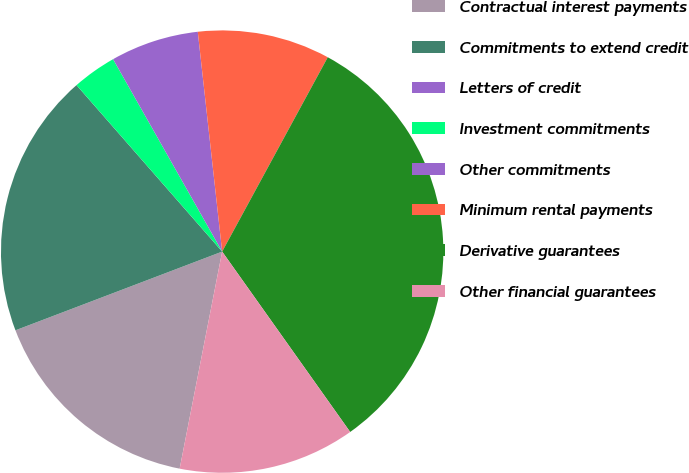Convert chart to OTSL. <chart><loc_0><loc_0><loc_500><loc_500><pie_chart><fcel>Contractual interest payments<fcel>Commitments to extend credit<fcel>Letters of credit<fcel>Investment commitments<fcel>Other commitments<fcel>Minimum rental payments<fcel>Derivative guarantees<fcel>Other financial guarantees<nl><fcel>16.13%<fcel>19.35%<fcel>0.0%<fcel>3.23%<fcel>6.45%<fcel>9.68%<fcel>32.25%<fcel>12.9%<nl></chart> 